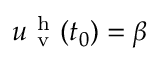Convert formula to latex. <formula><loc_0><loc_0><loc_500><loc_500>u _ { v } ^ { h } ( t _ { 0 } ) = \beta</formula> 